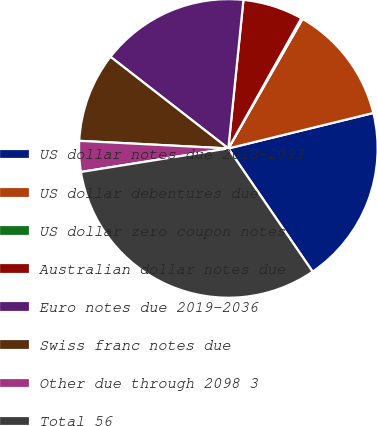<chart> <loc_0><loc_0><loc_500><loc_500><pie_chart><fcel>US dollar notes due 2018-2093<fcel>US dollar debentures due<fcel>US dollar zero coupon notes<fcel>Australian dollar notes due<fcel>Euro notes due 2019-2036<fcel>Swiss franc notes due<fcel>Other due through 2098 3<fcel>Total 56<nl><fcel>19.27%<fcel>12.9%<fcel>0.15%<fcel>6.52%<fcel>16.09%<fcel>9.71%<fcel>3.33%<fcel>32.03%<nl></chart> 